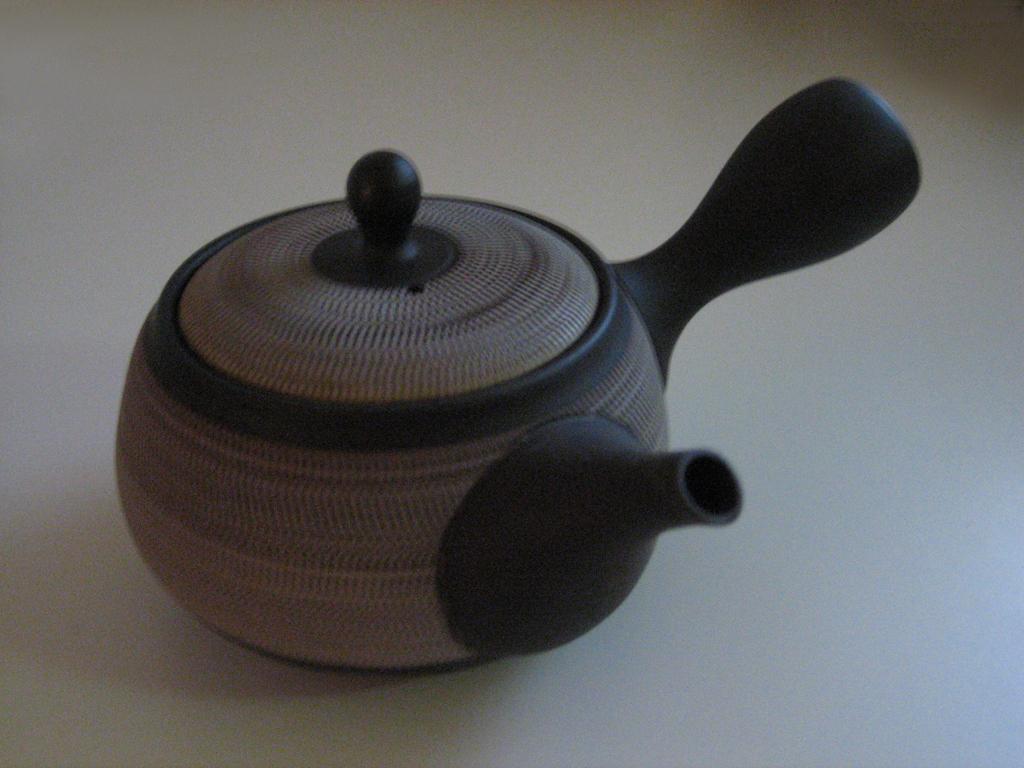Could you give a brief overview of what you see in this image? In the picture I can see an object on a surface. 